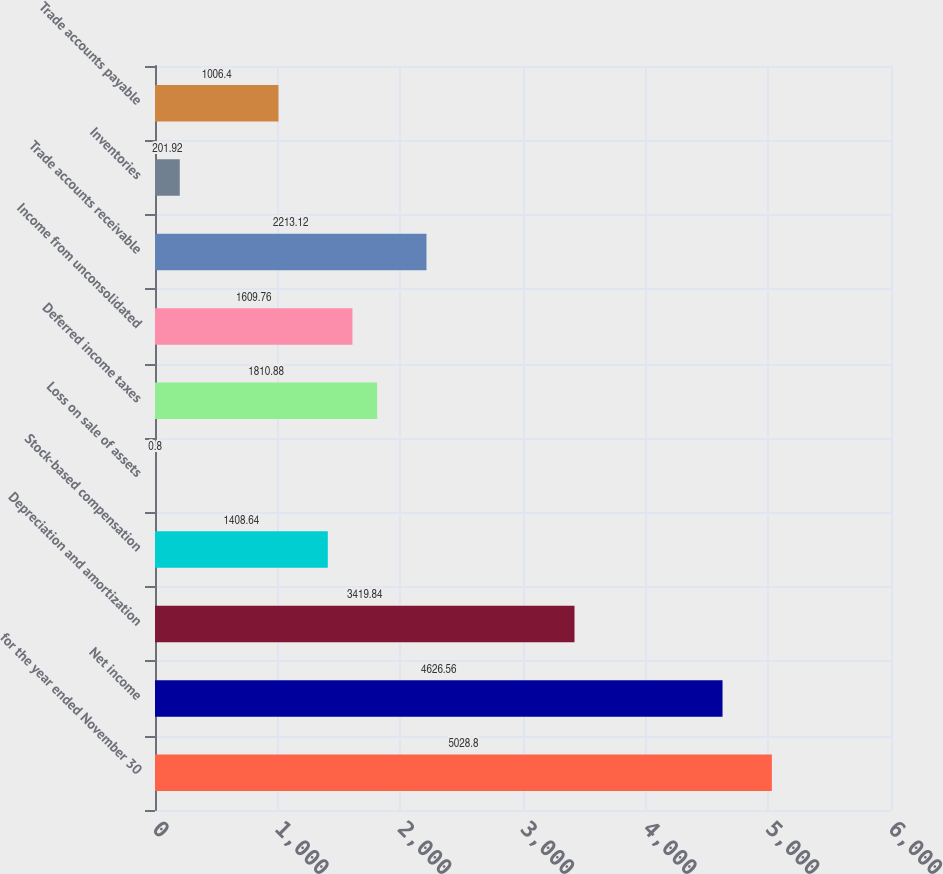Convert chart to OTSL. <chart><loc_0><loc_0><loc_500><loc_500><bar_chart><fcel>for the year ended November 30<fcel>Net income<fcel>Depreciation and amortization<fcel>Stock-based compensation<fcel>Loss on sale of assets<fcel>Deferred income taxes<fcel>Income from unconsolidated<fcel>Trade accounts receivable<fcel>Inventories<fcel>Trade accounts payable<nl><fcel>5028.8<fcel>4626.56<fcel>3419.84<fcel>1408.64<fcel>0.8<fcel>1810.88<fcel>1609.76<fcel>2213.12<fcel>201.92<fcel>1006.4<nl></chart> 